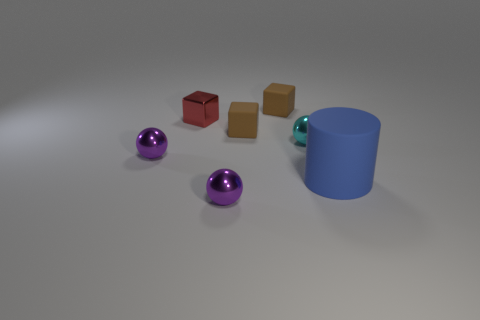Add 2 large red rubber objects. How many objects exist? 9 Subtract all balls. How many objects are left? 4 Add 5 tiny spheres. How many tiny spheres are left? 8 Add 7 large gray cylinders. How many large gray cylinders exist? 7 Subtract 0 cyan cubes. How many objects are left? 7 Subtract all large cyan metal spheres. Subtract all tiny cyan metal balls. How many objects are left? 6 